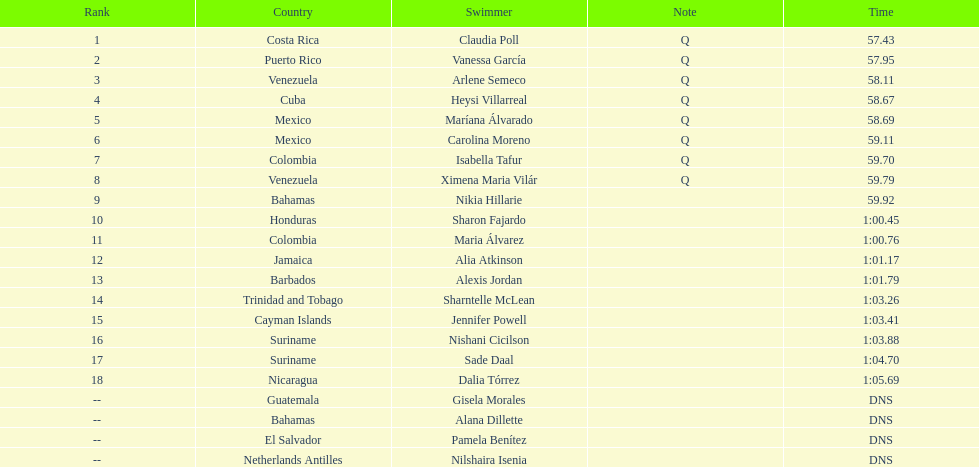How many competitors did not start the preliminaries? 4. 